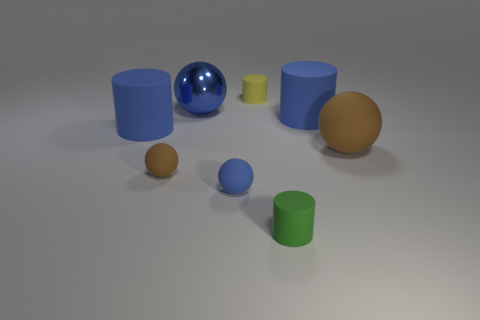Subtract all yellow cylinders. How many cylinders are left? 3 Subtract 1 cylinders. How many cylinders are left? 3 Subtract all metal balls. How many balls are left? 3 Subtract all brown cylinders. Subtract all gray blocks. How many cylinders are left? 4 Add 1 cyan things. How many objects exist? 9 Add 2 green cylinders. How many green cylinders exist? 3 Subtract 0 green blocks. How many objects are left? 8 Subtract all blue cylinders. Subtract all spheres. How many objects are left? 2 Add 3 large brown objects. How many large brown objects are left? 4 